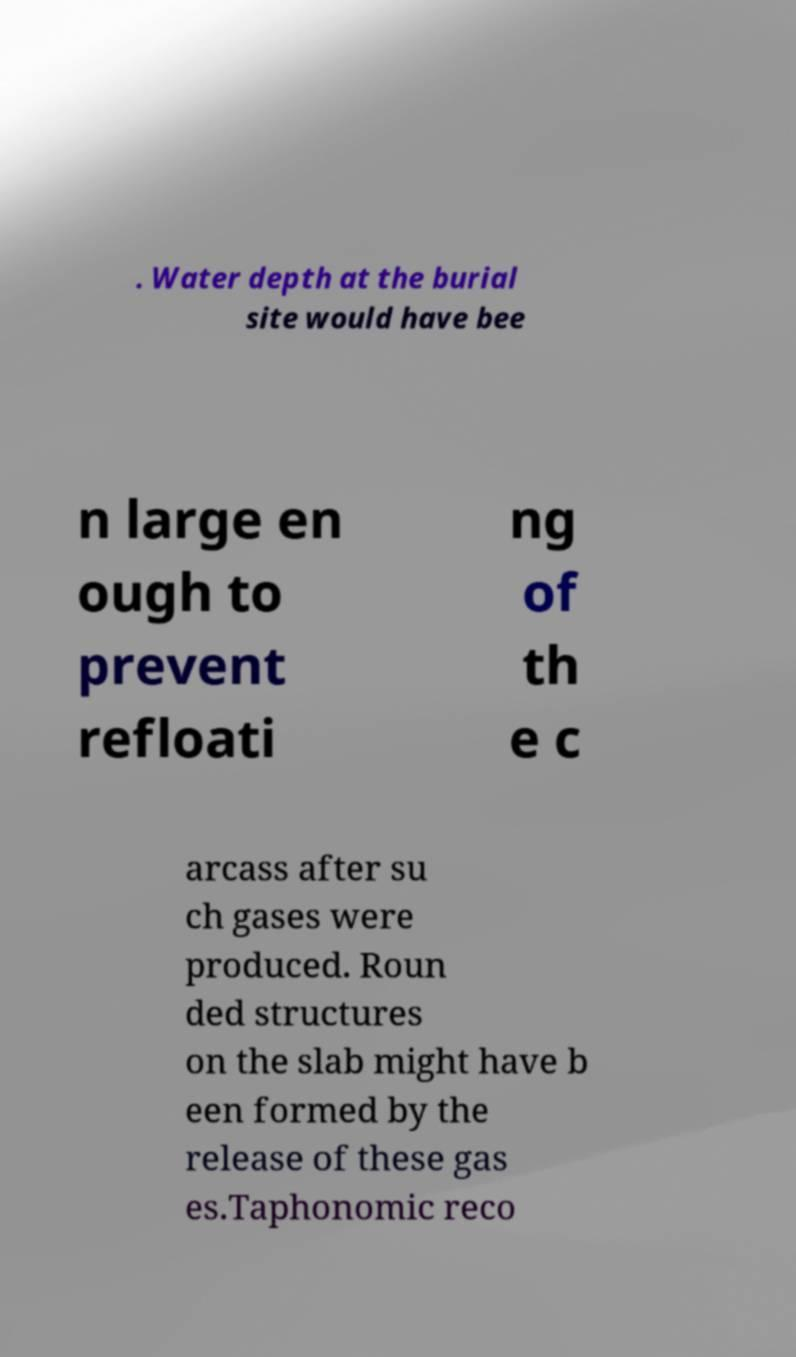What messages or text are displayed in this image? I need them in a readable, typed format. . Water depth at the burial site would have bee n large en ough to prevent refloati ng of th e c arcass after su ch gases were produced. Roun ded structures on the slab might have b een formed by the release of these gas es.Taphonomic reco 